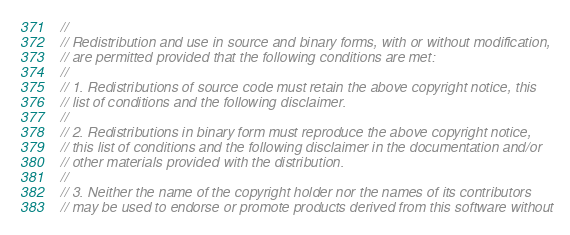<code> <loc_0><loc_0><loc_500><loc_500><_Cuda_>// 
// Redistribution and use in source and binary forms, with or without modification,
// are permitted provided that the following conditions are met:
// 
// 1. Redistributions of source code must retain the above copyright notice, this
// list of conditions and the following disclaimer.
// 
// 2. Redistributions in binary form must reproduce the above copyright notice,
// this list of conditions and the following disclaimer in the documentation and/or
// other materials provided with the distribution.
// 
// 3. Neither the name of the copyright holder nor the names of its contributors
// may be used to endorse or promote products derived from this software without</code> 